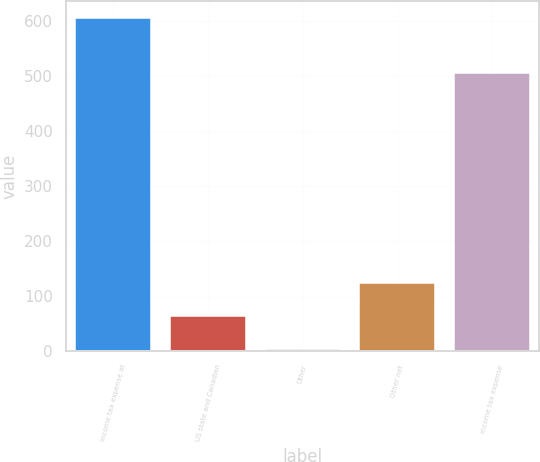Convert chart to OTSL. <chart><loc_0><loc_0><loc_500><loc_500><bar_chart><fcel>Income tax expense at<fcel>US state and Canadian<fcel>Other<fcel>Other net<fcel>Income tax expense<nl><fcel>606<fcel>63.3<fcel>3<fcel>123.6<fcel>505<nl></chart> 